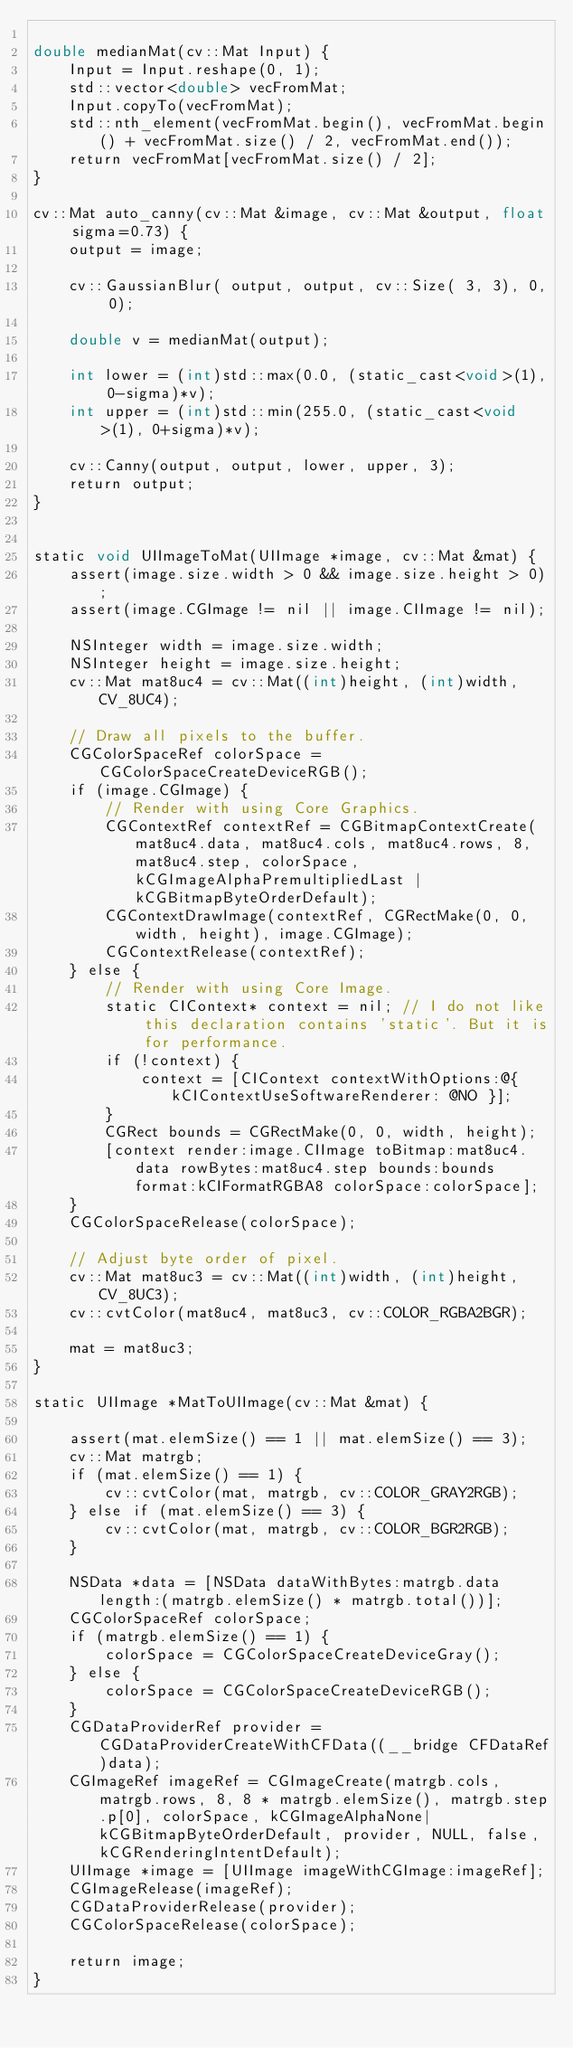Convert code to text. <code><loc_0><loc_0><loc_500><loc_500><_ObjectiveC_>
double medianMat(cv::Mat Input) {
    Input = Input.reshape(0, 1);
    std::vector<double> vecFromMat;
    Input.copyTo(vecFromMat);
    std::nth_element(vecFromMat.begin(), vecFromMat.begin() + vecFromMat.size() / 2, vecFromMat.end());
    return vecFromMat[vecFromMat.size() / 2];
}

cv::Mat auto_canny(cv::Mat &image, cv::Mat &output, float sigma=0.73) {
    output = image;

    cv::GaussianBlur( output, output, cv::Size( 3, 3), 0, 0);

    double v = medianMat(output);

    int lower = (int)std::max(0.0, (static_cast<void>(1), 0-sigma)*v);
    int upper = (int)std::min(255.0, (static_cast<void>(1), 0+sigma)*v);

    cv::Canny(output, output, lower, upper, 3);
    return output;
}


static void UIImageToMat(UIImage *image, cv::Mat &mat) {
	assert(image.size.width > 0 && image.size.height > 0);
	assert(image.CGImage != nil || image.CIImage != nil);

	NSInteger width = image.size.width;
	NSInteger height = image.size.height;
	cv::Mat mat8uc4 = cv::Mat((int)height, (int)width, CV_8UC4);

	// Draw all pixels to the buffer.
	CGColorSpaceRef colorSpace = CGColorSpaceCreateDeviceRGB();
	if (image.CGImage) {
		// Render with using Core Graphics.
		CGContextRef contextRef = CGBitmapContextCreate(mat8uc4.data, mat8uc4.cols, mat8uc4.rows, 8, mat8uc4.step, colorSpace, kCGImageAlphaPremultipliedLast | kCGBitmapByteOrderDefault);
		CGContextDrawImage(contextRef, CGRectMake(0, 0, width, height), image.CGImage);
		CGContextRelease(contextRef);
	} else {
		// Render with using Core Image.
		static CIContext* context = nil; // I do not like this declaration contains 'static'. But it is for performance.
		if (!context) {
			context = [CIContext contextWithOptions:@{ kCIContextUseSoftwareRenderer: @NO }];
		}
		CGRect bounds = CGRectMake(0, 0, width, height);
		[context render:image.CIImage toBitmap:mat8uc4.data rowBytes:mat8uc4.step bounds:bounds format:kCIFormatRGBA8 colorSpace:colorSpace];
	}
	CGColorSpaceRelease(colorSpace);

	// Adjust byte order of pixel.
	cv::Mat mat8uc3 = cv::Mat((int)width, (int)height, CV_8UC3);
	cv::cvtColor(mat8uc4, mat8uc3, cv::COLOR_RGBA2BGR);
	
	mat = mat8uc3;
}

static UIImage *MatToUIImage(cv::Mat &mat) {
	
	assert(mat.elemSize() == 1 || mat.elemSize() == 3);
	cv::Mat matrgb;
	if (mat.elemSize() == 1) {
		cv::cvtColor(mat, matrgb, cv::COLOR_GRAY2RGB);
    } else if (mat.elemSize() == 3) {
        cv::cvtColor(mat, matrgb, cv::COLOR_BGR2RGB);
    }
	
	NSData *data = [NSData dataWithBytes:matrgb.data length:(matrgb.elemSize() * matrgb.total())];
	CGColorSpaceRef colorSpace;
	if (matrgb.elemSize() == 1) {
		colorSpace = CGColorSpaceCreateDeviceGray();
	} else {
		colorSpace = CGColorSpaceCreateDeviceRGB();
	}
	CGDataProviderRef provider = CGDataProviderCreateWithCFData((__bridge CFDataRef)data);
	CGImageRef imageRef = CGImageCreate(matrgb.cols, matrgb.rows, 8, 8 * matrgb.elemSize(), matrgb.step.p[0], colorSpace, kCGImageAlphaNone|kCGBitmapByteOrderDefault, provider, NULL, false, kCGRenderingIntentDefault);
	UIImage *image = [UIImage imageWithCGImage:imageRef];
	CGImageRelease(imageRef);
	CGDataProviderRelease(provider);
	CGColorSpaceRelease(colorSpace);
	
	return image;
}

</code> 